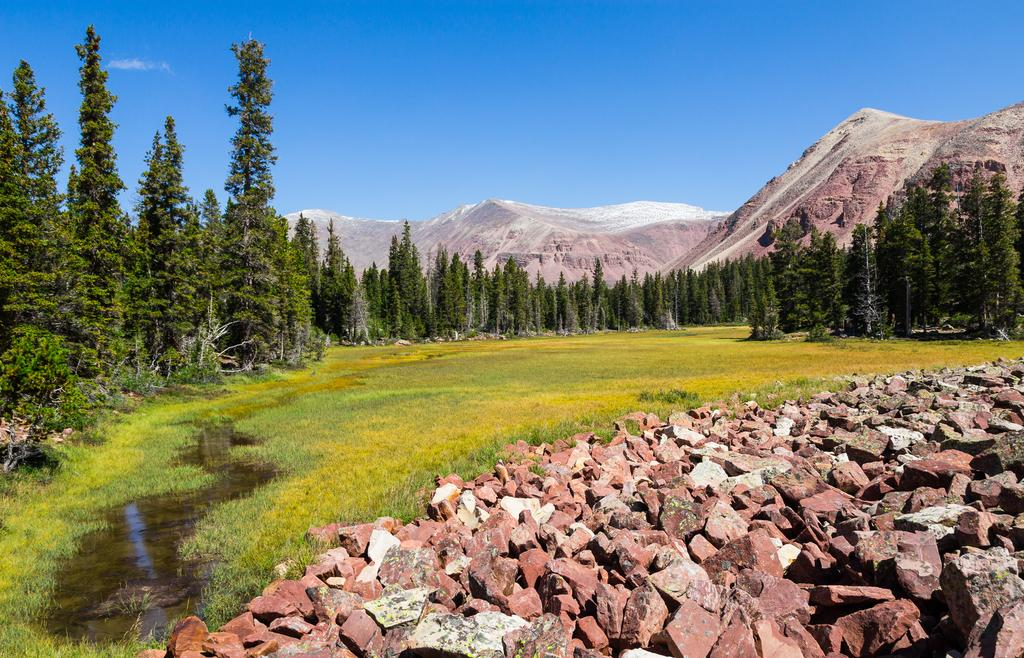What type of vegetation can be seen in the image? There are trees and grass visible in the image. What natural feature is present in the image? There is water visible in the image. What type of material is used in the construction of the structure in the image? Bricks are present in the image. What geographical feature can be seen in the distance? There are mountains in the image. What is visible in the sky in the image? The sky is visible in the image, and clouds are present. What type of cactus can be seen growing in the water in the image? There is no cactus present in the image, and no plants are growing in the water. 